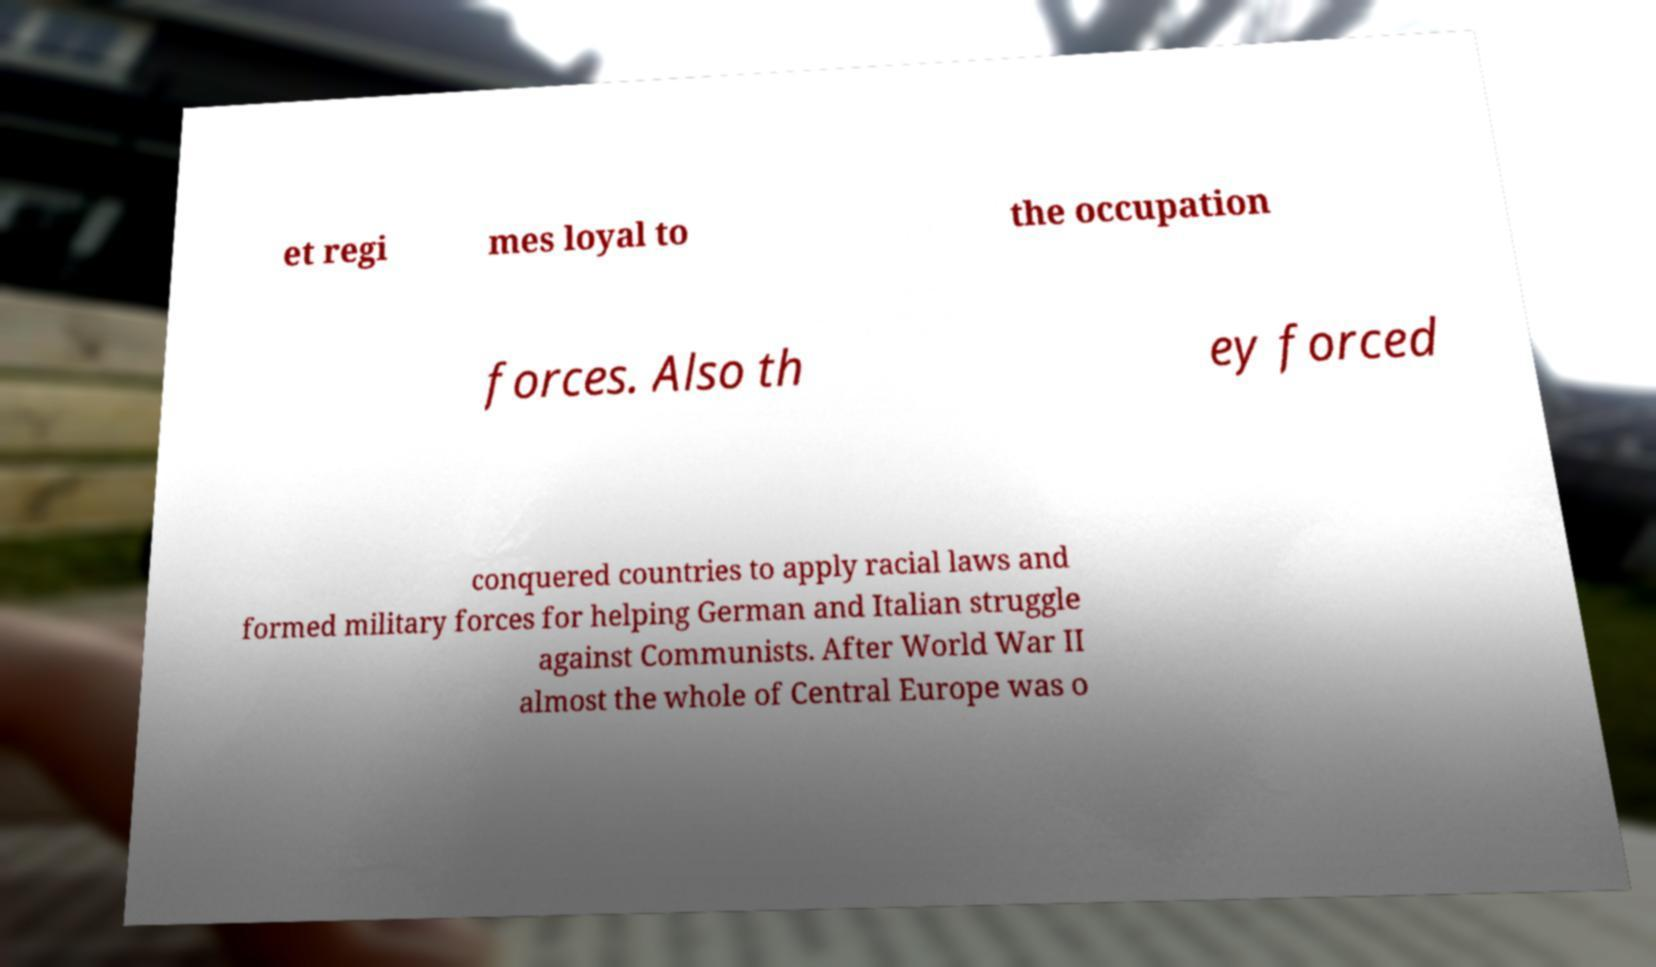There's text embedded in this image that I need extracted. Can you transcribe it verbatim? et regi mes loyal to the occupation forces. Also th ey forced conquered countries to apply racial laws and formed military forces for helping German and Italian struggle against Communists. After World War II almost the whole of Central Europe was o 